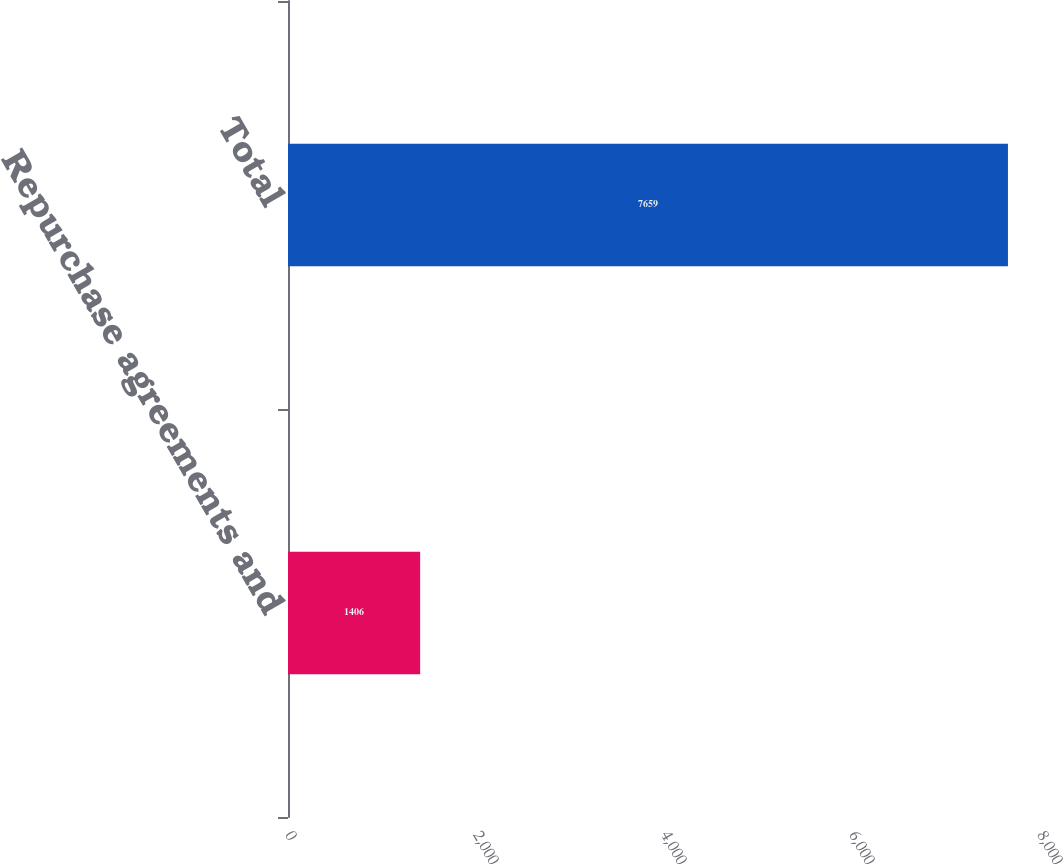Convert chart. <chart><loc_0><loc_0><loc_500><loc_500><bar_chart><fcel>Repurchase agreements and<fcel>Total<nl><fcel>1406<fcel>7659<nl></chart> 